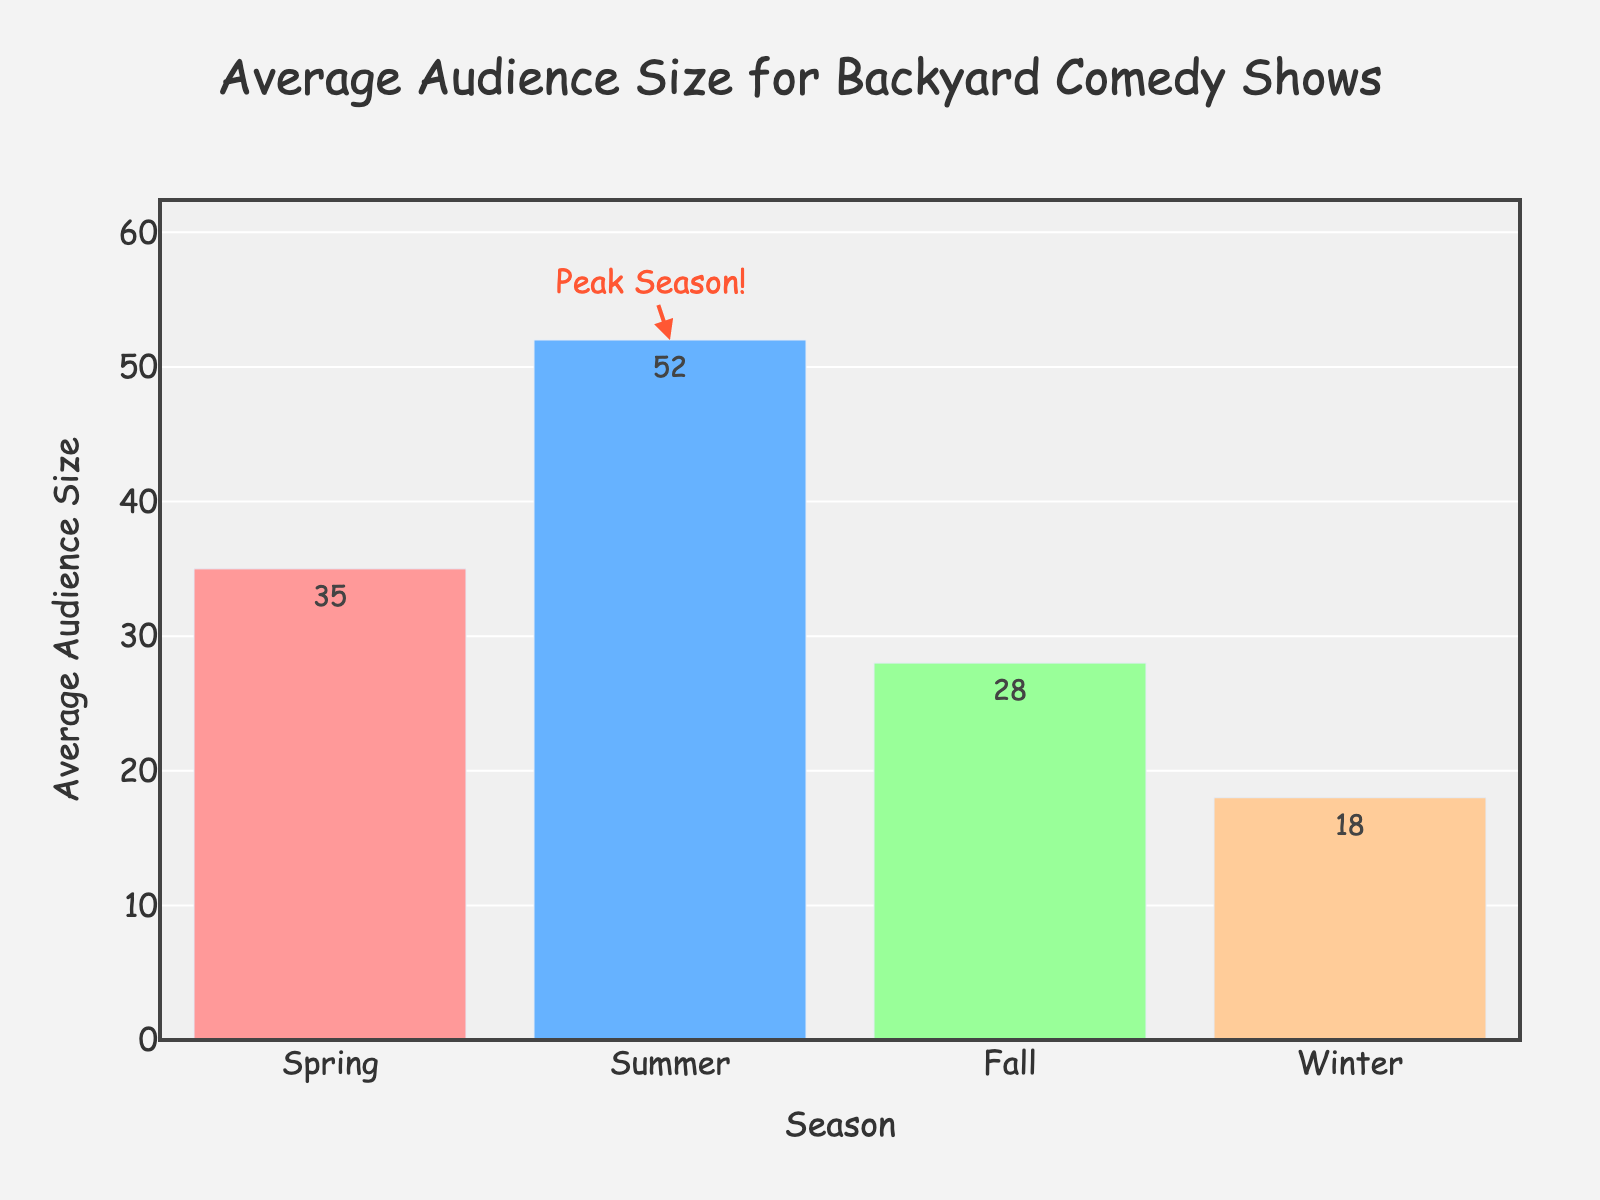What season has the highest average audience size for backyard comedy shows? The highest bar on the chart represents the season with the highest average audience size, which is Summer.
Answer: Summer What is the total average audience size for all seasons combined? To get the total, sum up the average audience sizes of all seasons: 35 (Spring) + 52 (Summer) + 28 (Fall) + 18 (Winter) = 133.
Answer: 133 How much larger is the average audience size in Summer compared to Winter? Subtract the average audience size of Winter from Summer: 52 (Summer) - 18 (Winter) = 34.
Answer: 34 Which season has the smallest average audience size? The shortest bar on the chart represents the season with the smallest average audience size, which is Winter.
Answer: Winter What is the difference in average audience size between the season with the largest audience and the season with the second-largest audience? Identify the seasons: Summer (52) and Spring (35). Calculate the difference: 52 - 35 = 17.
Answer: 17 How much more popular are the backyard comedy shows in Summer than in Fall? Subtract the average audience size of Fall from Summer: 52 (Summer) - 28 (Fall) = 24.
Answer: 24 What is the average audience size of the seasons excluding Summer? Sum the average audience sizes of Spring, Fall, and Winter, and then divide by 3: (35 + 28 + 18) / 3 = 81 / 3 = 27.
Answer: 27 What is the peak season for backyard comedy shows? The annotation on the chart marks Summer as the "Peak Season!" with an arrow pointing to it.
Answer: Summer 